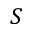<formula> <loc_0><loc_0><loc_500><loc_500>S</formula> 